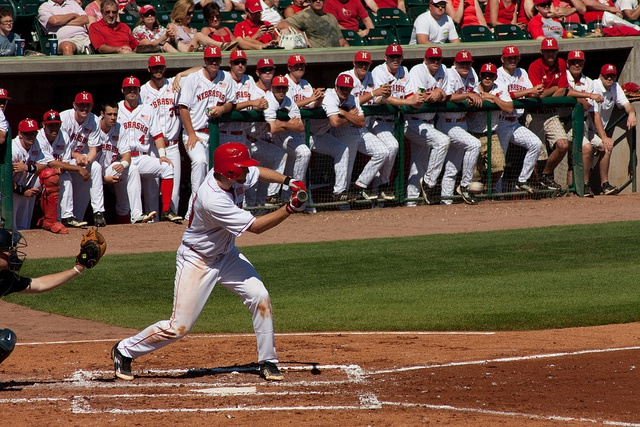Describe the objects in this image and their specific colors. I can see people in black, gray, and lightgray tones, people in black, lightgray, gray, darkgray, and maroon tones, people in black, lavender, darkgray, and brown tones, people in black, maroon, and brown tones, and people in black, lavender, brown, and darkgray tones in this image. 